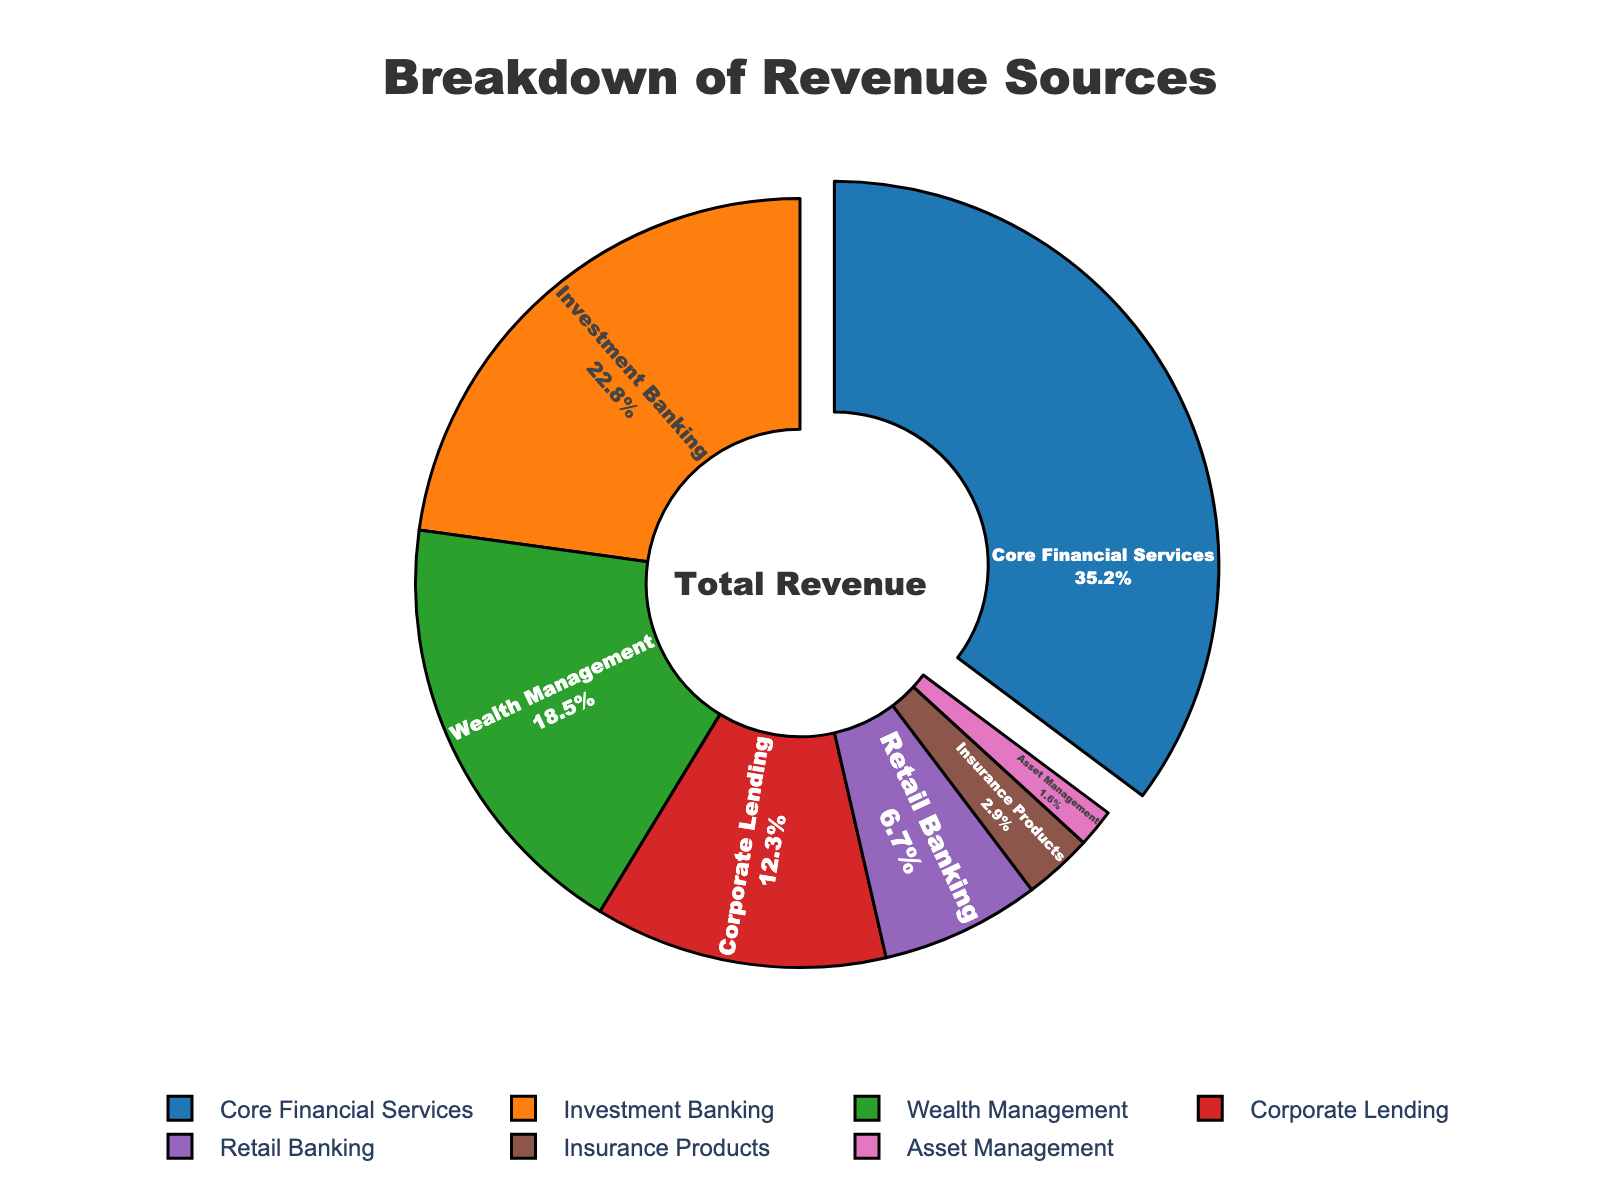What percentage of total revenue comes from Wealth Management and Investment Banking combined? Add the percentages of Wealth Management (18.5%) and Investment Banking (22.8%). 18.5 + 22.8 = 41.3%
Answer: 41.3% Which category contributes the least to the total revenue, and what is its percentage? The category with the smallest segment in the pie chart corresponds to Asset Management with a percentage of 1.6%.
Answer: Asset Management, 1.6% Is the revenue from Core Financial Services more than the combined revenue from Retail Banking and Insurance Products? Compare Core Financial Services (35.2%) with the sum of Retail Banking (6.7%) and Insurance Products (2.9%). 6.7 + 2.9 = 9.6%, which is less than 35.2%.
Answer: Yes What is the visual significance of the pulled-out segment in the pie chart? The pulled-out segment highlights the category with the highest revenue percentage, which is Core Financial Services at 35.2%.
Answer: Core Financial Services has the highest revenue at 35.2% How much more revenue percentage does Corporate Lending generate compared to Asset Management? Subtract the percentage of Asset Management (1.6%) from Corporate Lending (12.3%). 12.3 - 1.6 = 10.7%
Answer: 10.7% Which two categories contribute nearly the same percentage to the total revenue, and what are their percentages? Identify two segments with close percentages. Corporate Lending (12.3%) and Retail Banking (6.7%) are not close. Wealth Management (18.5%) and Investment Banking (22.8%) are also not close. There is no pair with nearly the same percentage.
Answer: None What's the difference in revenue percentages between Core Financial Services and Corporate Lending? Subtract the percentage of Corporate Lending (12.3%) from Core Financial Services (35.2%). 35.2 - 12.3 = 22.9%
Answer: 22.9% What is the approximate contribution of the smallest three categories to the total revenue? Add the percentages of the smallest three categories: Retail Banking (6.7%), Insurance Products (2.9%), and Asset Management (1.6%). 6.7 + 2.9 + 1.6 = 11.2%
Answer: 11.2% Which category is shown in blue and what is its revenue percentage? Identify the category based on the color. Core Financial Services is shown in blue with a revenue percentage of 35.2%.
Answer: Core Financial Services, 35.2% If you combine Wealth Management and Insurance Products, do they surpass the revenue percentage of Core Financial Services? Sum Wealth Management (18.5%) and Insurance Products (2.9%). 18.5 + 2.9 = 21.4%, which is less than 35.2%.
Answer: No 